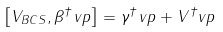<formula> <loc_0><loc_0><loc_500><loc_500>\left [ V _ { B C S } , \beta ^ { \dagger } _ { \ } v p \right ] = \gamma ^ { \dagger } _ { \ } v p + V ^ { \dagger } _ { \ } v p</formula> 